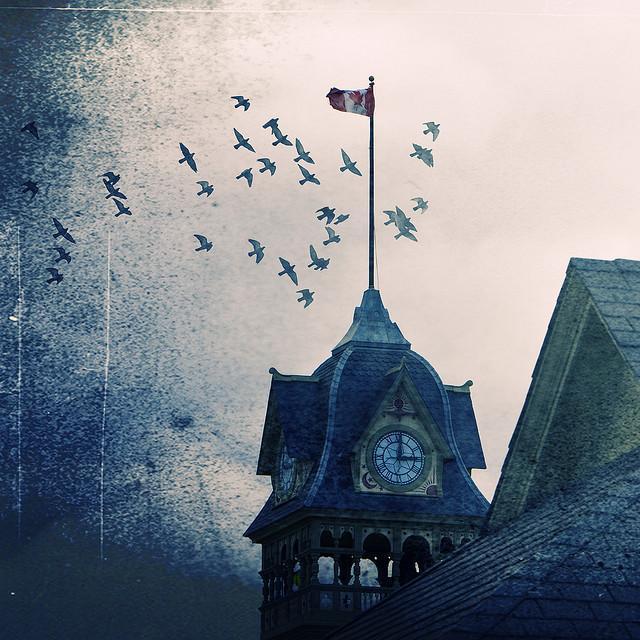How many flags are there?
Give a very brief answer. 1. 